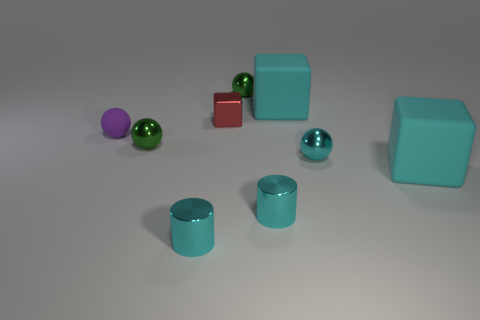Subtract all cubes. How many objects are left? 6 Add 5 purple things. How many purple things are left? 6 Add 2 tiny purple matte balls. How many tiny purple matte balls exist? 3 Subtract 0 blue balls. How many objects are left? 9 Subtract all green spheres. Subtract all small metallic cubes. How many objects are left? 6 